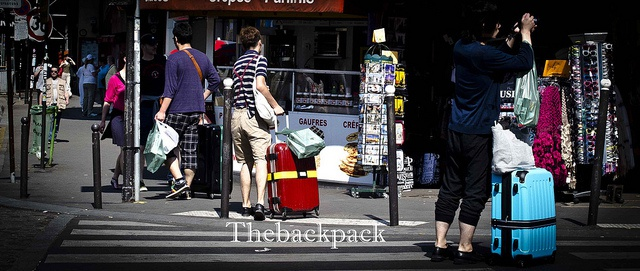Describe the objects in this image and their specific colors. I can see people in black, gray, navy, and darkgray tones, people in black, ivory, gray, and darkgray tones, suitcase in black, lightblue, and teal tones, people in black, navy, and purple tones, and suitcase in black, maroon, white, and darkgray tones in this image. 